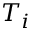<formula> <loc_0><loc_0><loc_500><loc_500>T _ { i }</formula> 